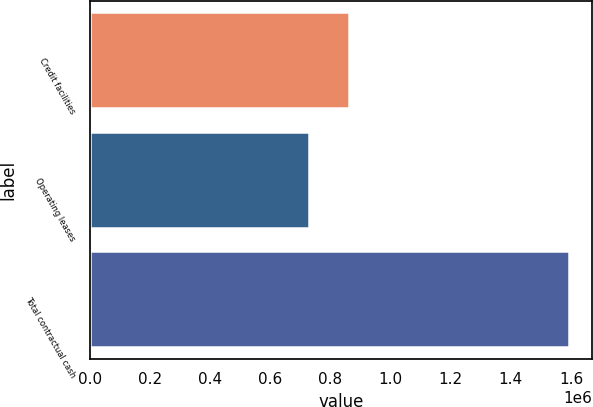Convert chart to OTSL. <chart><loc_0><loc_0><loc_500><loc_500><bar_chart><fcel>Credit facilities<fcel>Operating leases<fcel>Total contractual cash<nl><fcel>863212<fcel>728600<fcel>1.59181e+06<nl></chart> 